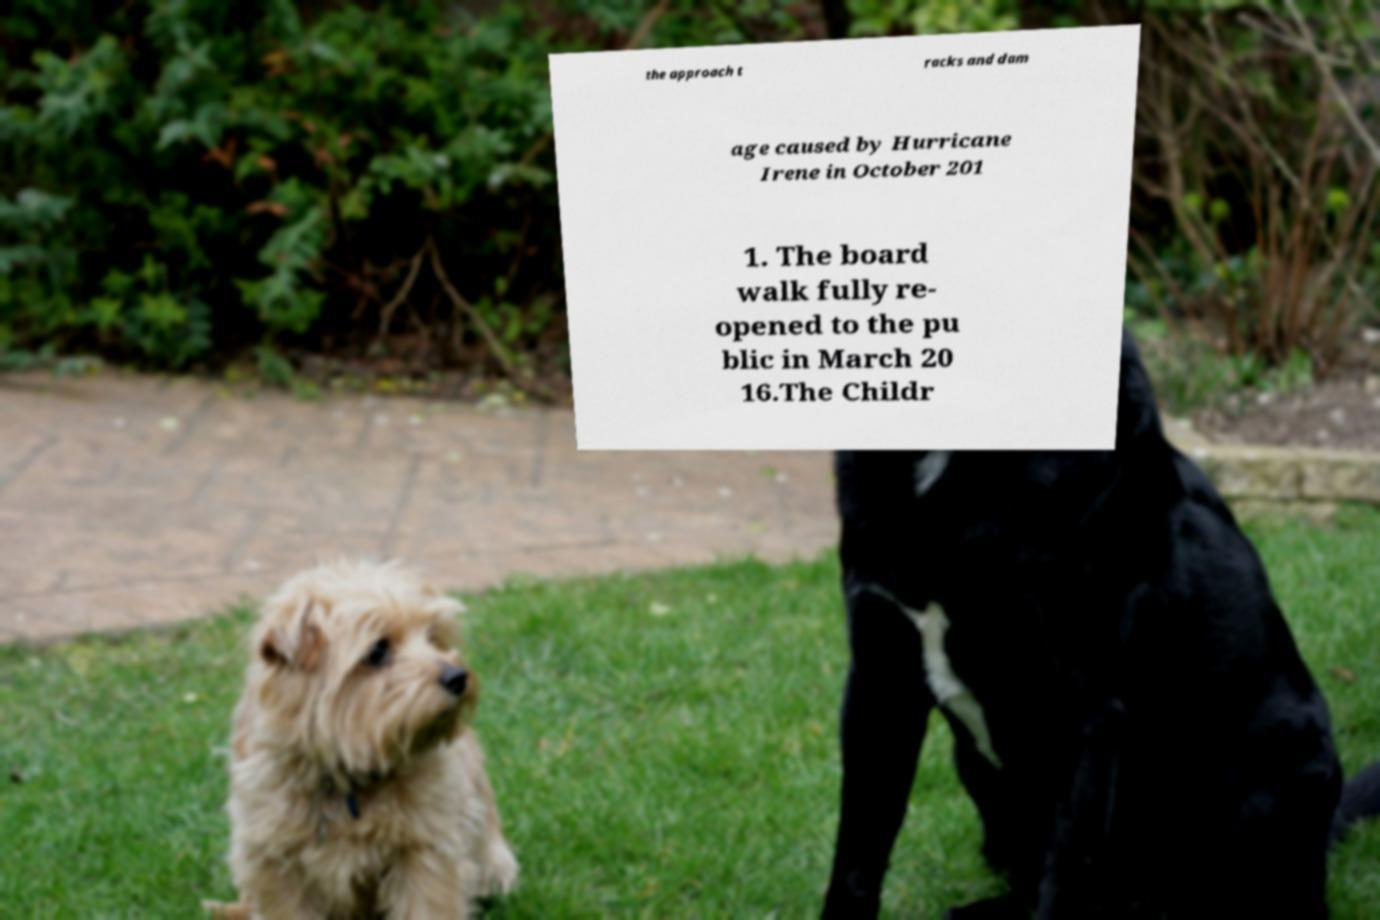Could you extract and type out the text from this image? the approach t racks and dam age caused by Hurricane Irene in October 201 1. The board walk fully re- opened to the pu blic in March 20 16.The Childr 